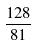Convert formula to latex. <formula><loc_0><loc_0><loc_500><loc_500>\frac { 1 2 8 } { 8 1 }</formula> 